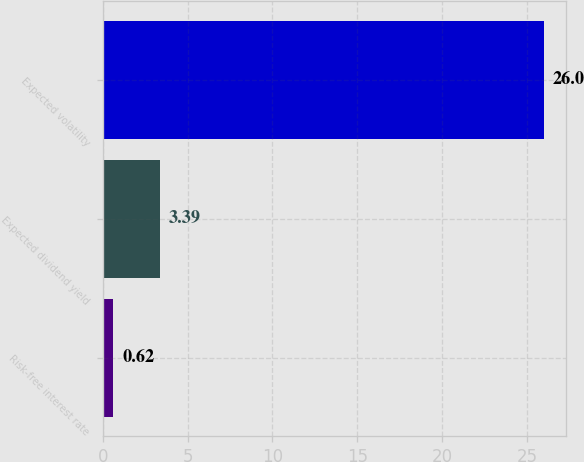<chart> <loc_0><loc_0><loc_500><loc_500><bar_chart><fcel>Risk-free interest rate<fcel>Expected dividend yield<fcel>Expected volatility<nl><fcel>0.62<fcel>3.39<fcel>26<nl></chart> 